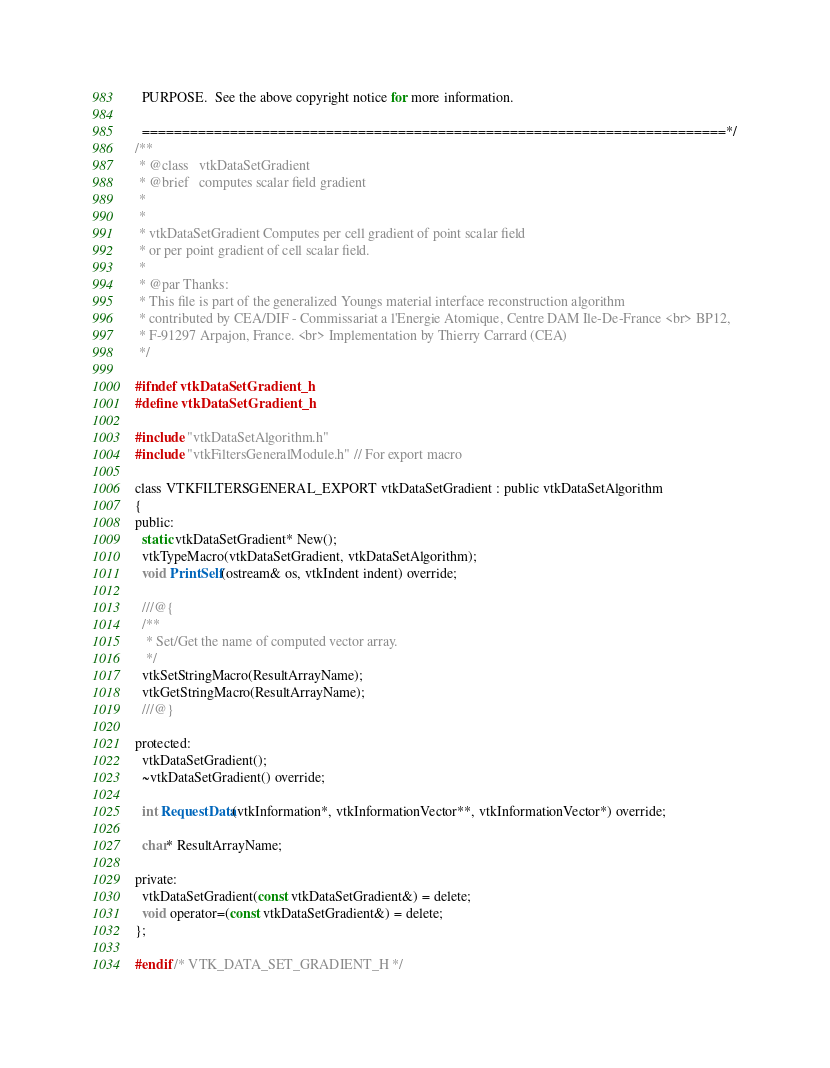<code> <loc_0><loc_0><loc_500><loc_500><_C_>  PURPOSE.  See the above copyright notice for more information.

  =========================================================================*/
/**
 * @class   vtkDataSetGradient
 * @brief   computes scalar field gradient
 *
 *
 * vtkDataSetGradient Computes per cell gradient of point scalar field
 * or per point gradient of cell scalar field.
 *
 * @par Thanks:
 * This file is part of the generalized Youngs material interface reconstruction algorithm
 * contributed by CEA/DIF - Commissariat a l'Energie Atomique, Centre DAM Ile-De-France <br> BP12,
 * F-91297 Arpajon, France. <br> Implementation by Thierry Carrard (CEA)
 */

#ifndef vtkDataSetGradient_h
#define vtkDataSetGradient_h

#include "vtkDataSetAlgorithm.h"
#include "vtkFiltersGeneralModule.h" // For export macro

class VTKFILTERSGENERAL_EXPORT vtkDataSetGradient : public vtkDataSetAlgorithm
{
public:
  static vtkDataSetGradient* New();
  vtkTypeMacro(vtkDataSetGradient, vtkDataSetAlgorithm);
  void PrintSelf(ostream& os, vtkIndent indent) override;

  ///@{
  /**
   * Set/Get the name of computed vector array.
   */
  vtkSetStringMacro(ResultArrayName);
  vtkGetStringMacro(ResultArrayName);
  ///@}

protected:
  vtkDataSetGradient();
  ~vtkDataSetGradient() override;

  int RequestData(vtkInformation*, vtkInformationVector**, vtkInformationVector*) override;

  char* ResultArrayName;

private:
  vtkDataSetGradient(const vtkDataSetGradient&) = delete;
  void operator=(const vtkDataSetGradient&) = delete;
};

#endif /* VTK_DATA_SET_GRADIENT_H */
</code> 